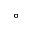<formula> <loc_0><loc_0><loc_500><loc_500>^ { \circ }</formula> 